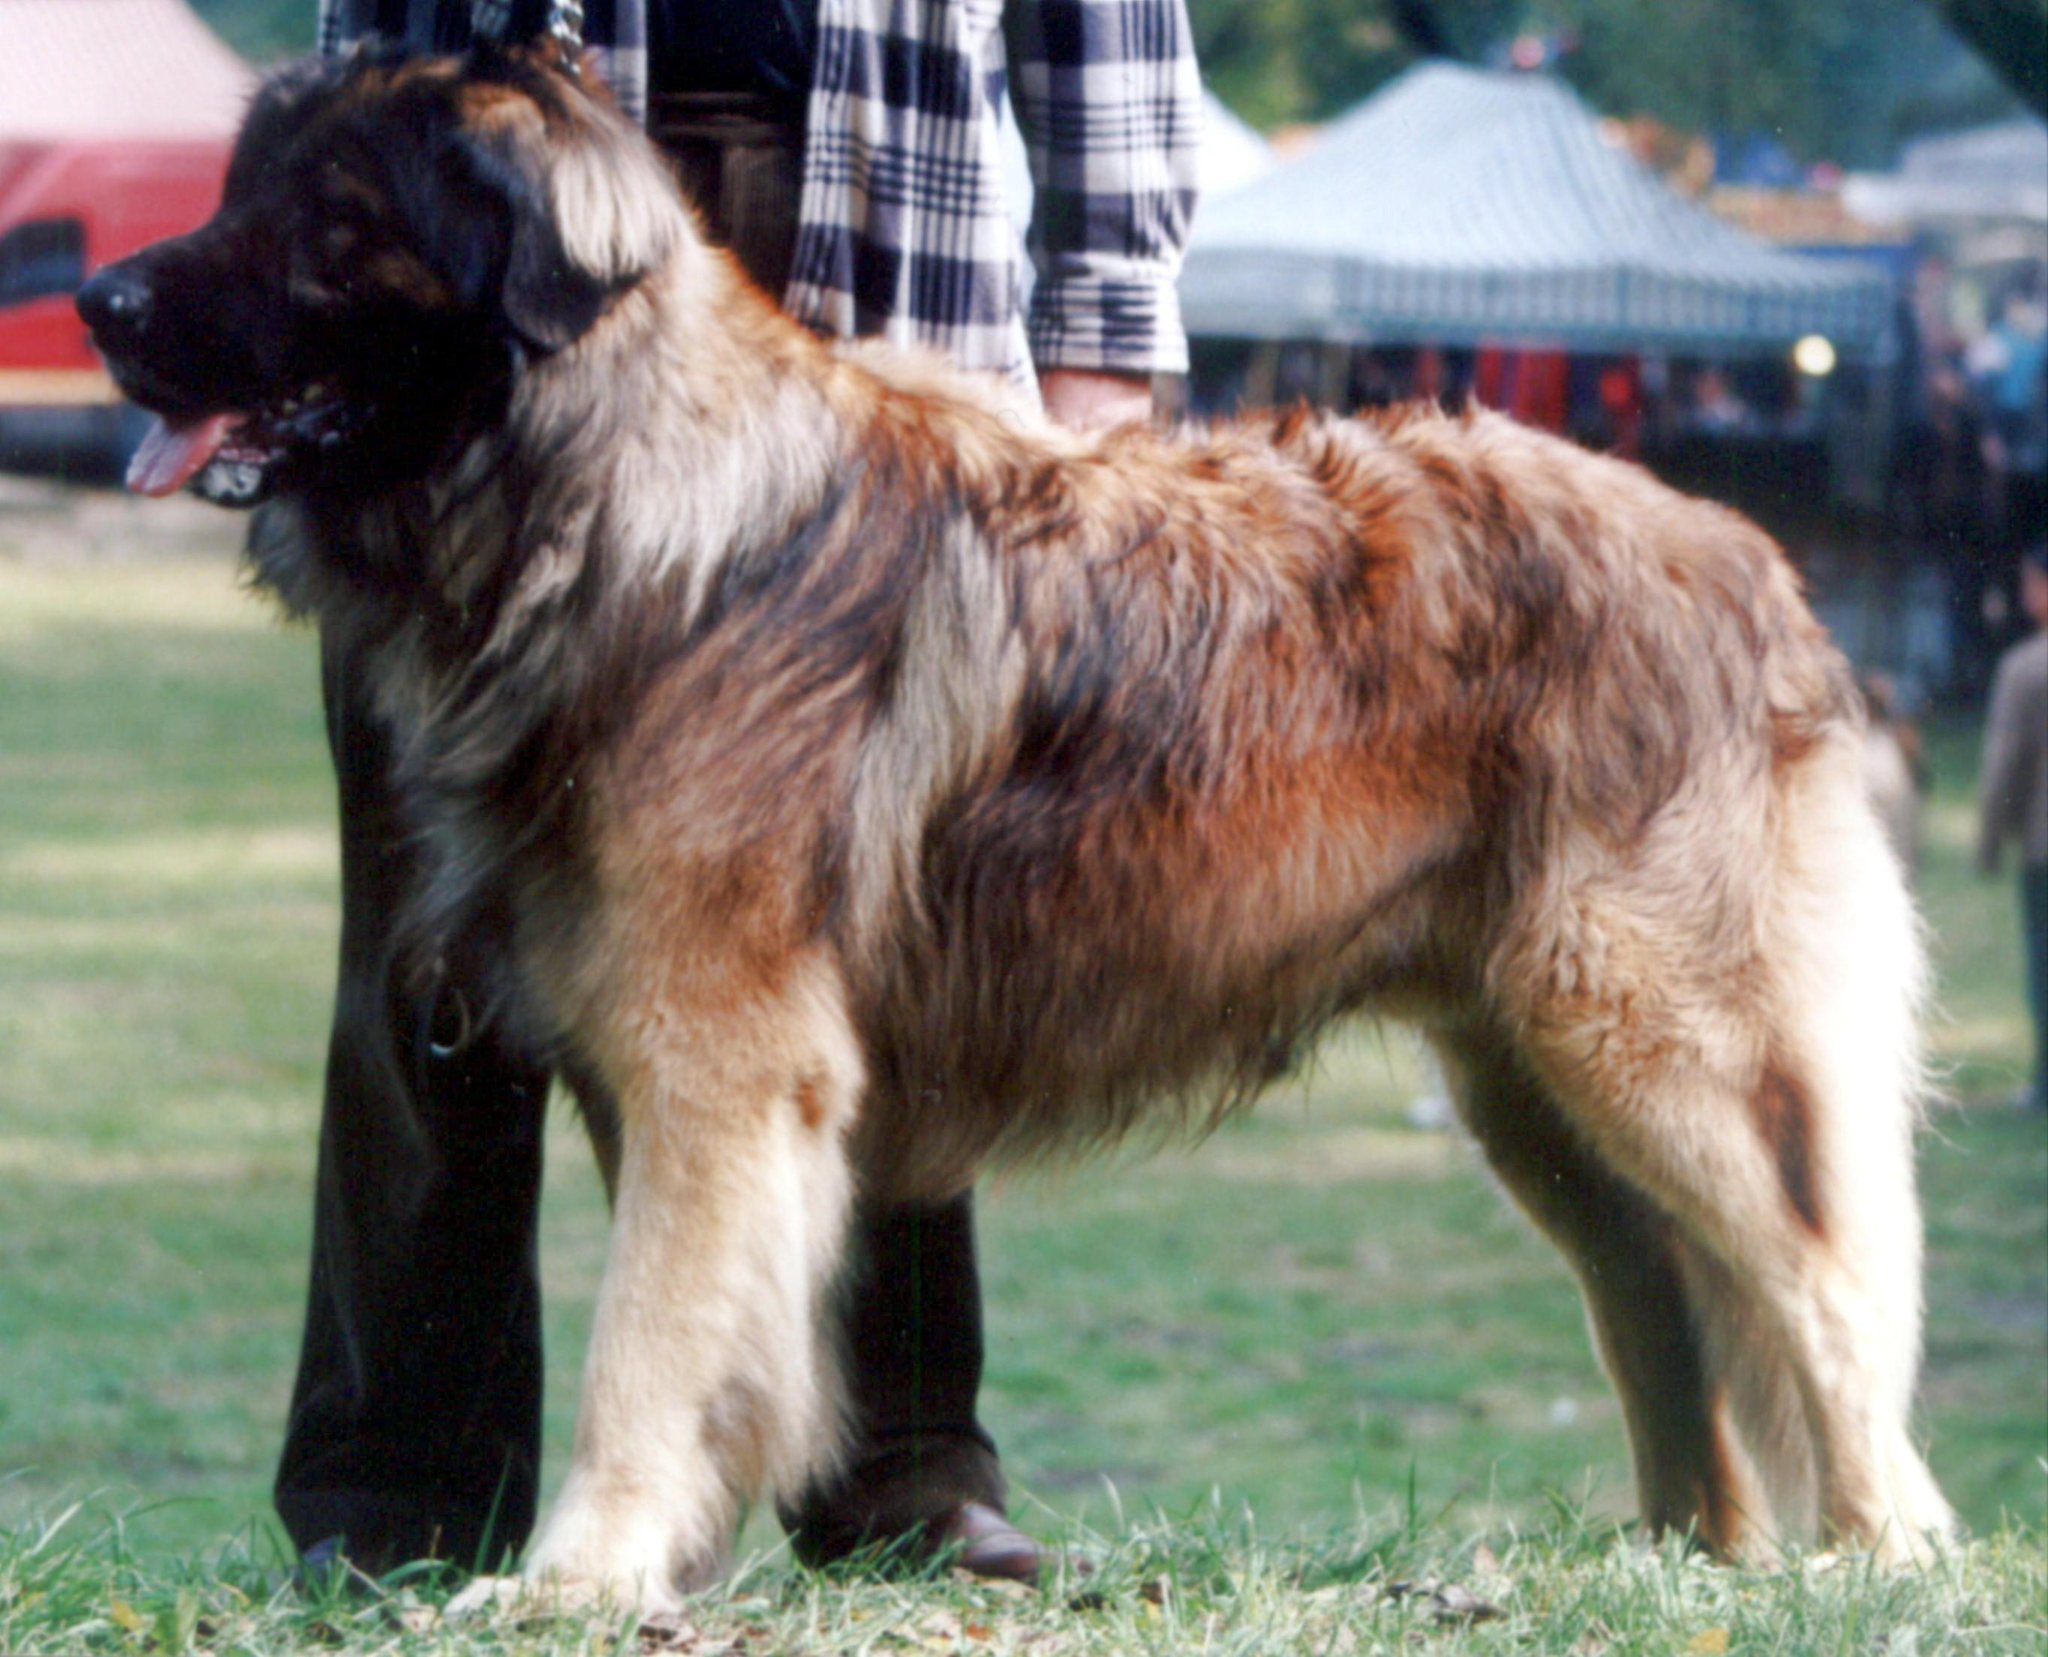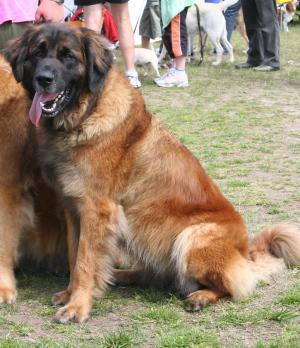The first image is the image on the left, the second image is the image on the right. Examine the images to the left and right. Is the description "We've got two dogs here." accurate? Answer yes or no. Yes. 